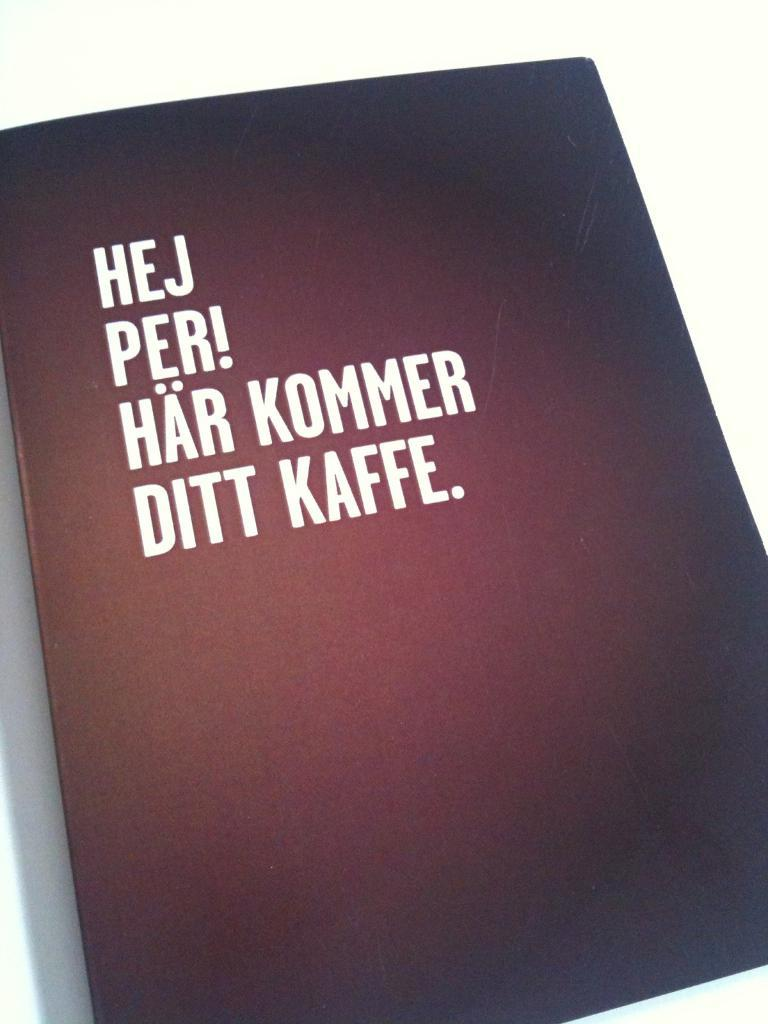<image>
Write a terse but informative summary of the picture. a black book with Hej Per! Har Kommer Ditt Kaffe on it 